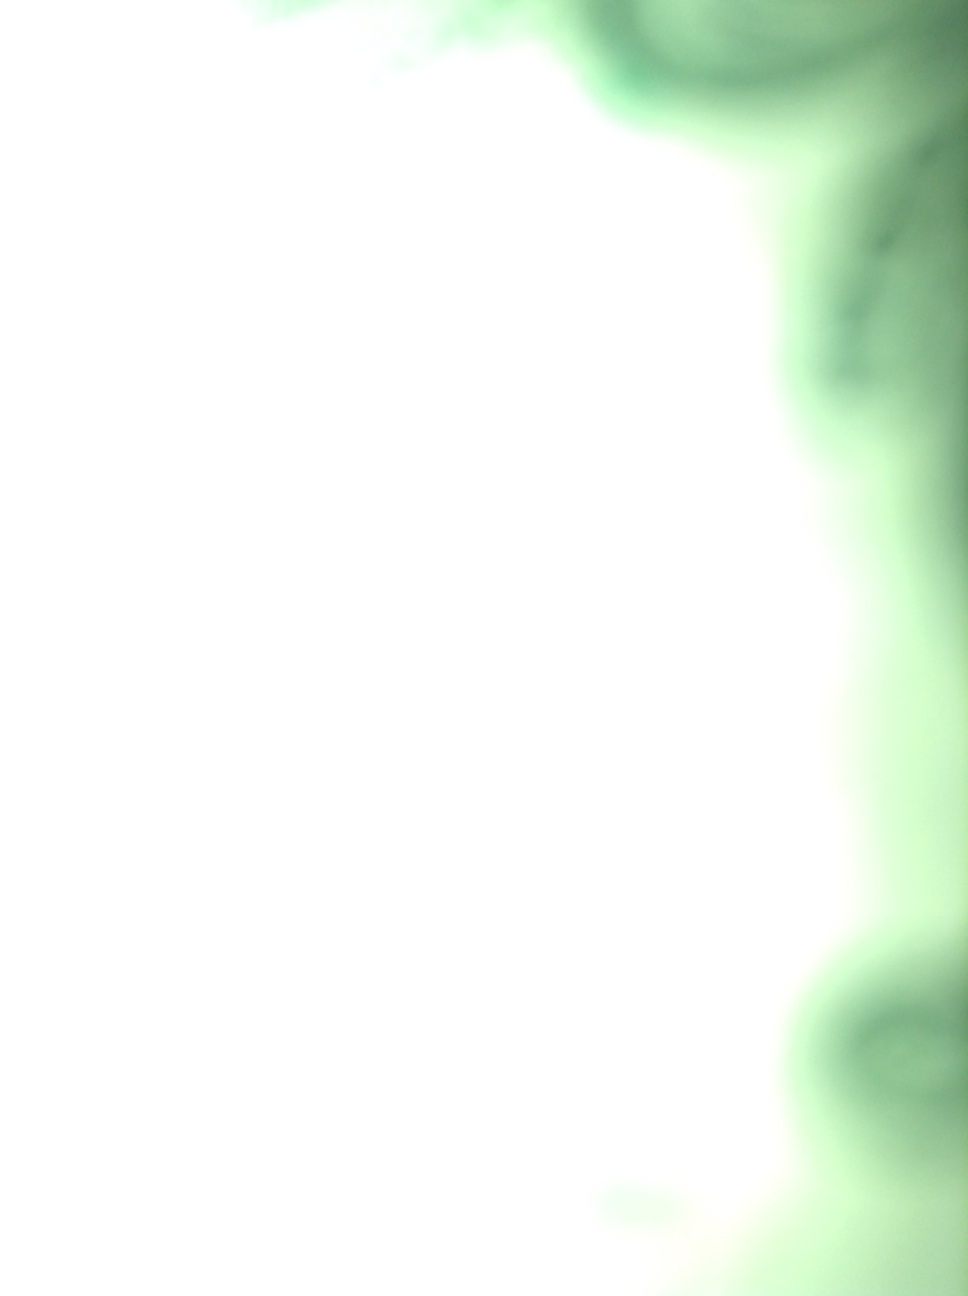Is there any identifiable object at all in this image? Given the extreme blurriness of the image, it's hard to confidently identify any objects. The photo predominantly shows an overexposed green tint with vague, indiscernible shapes. Could these shapes possibly be something specific or are they too blurred to tell? They are too blurred to specifically identify. It appears more like an accidental capture of light and color rather than a focused image of identifiable objects. 